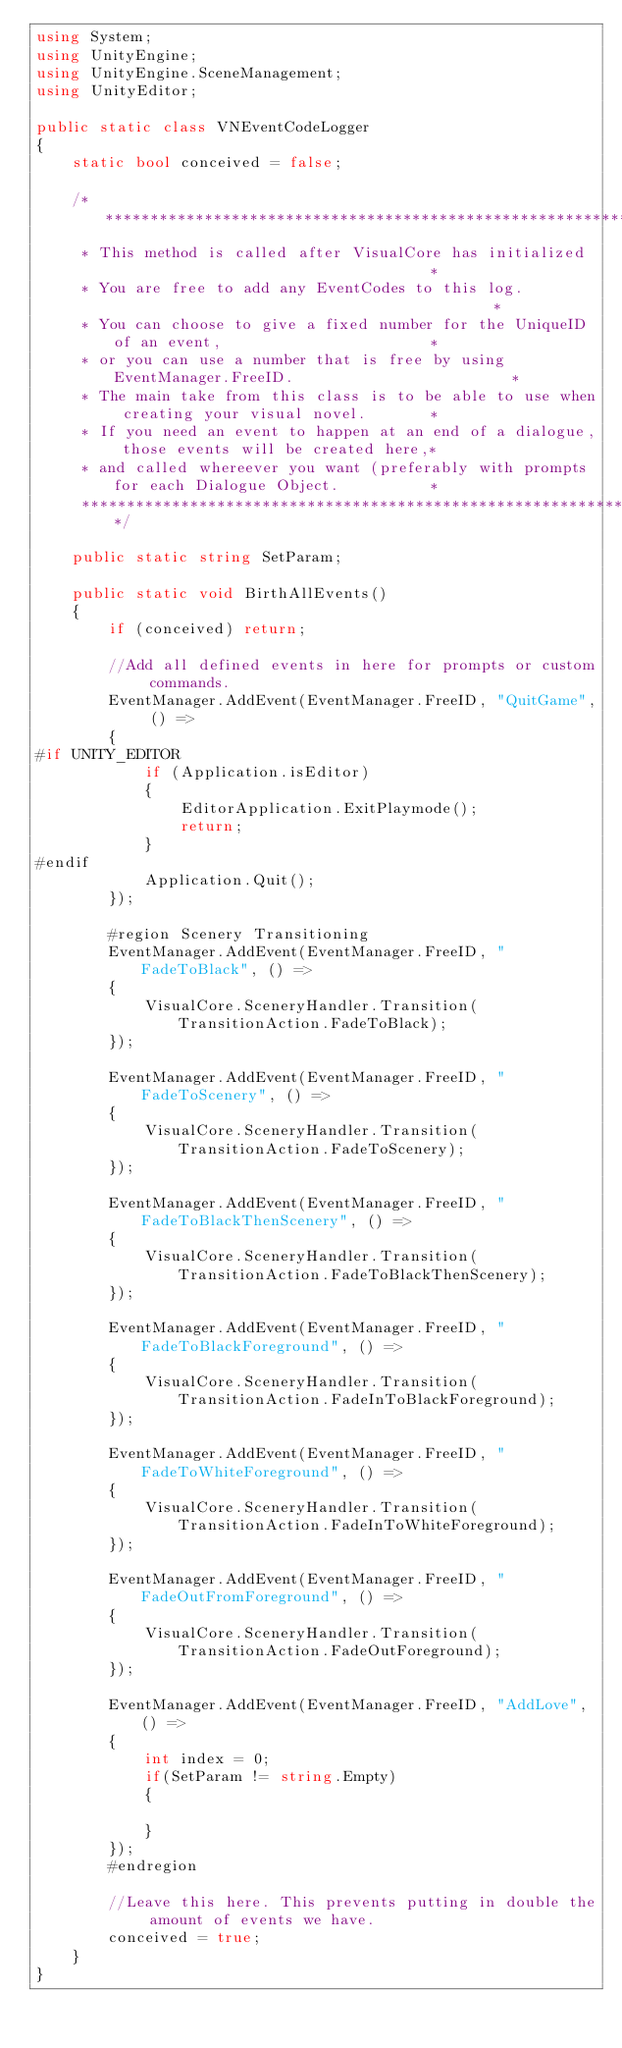<code> <loc_0><loc_0><loc_500><loc_500><_C#_>using System;
using UnityEngine;
using UnityEngine.SceneManagement;
using UnityEditor;

public static class VNEventCodeLogger
{
    static bool conceived = false;

    /*********************************************************************************************
     * This method is called after VisualCore has initialized                                    *
     * You are free to add any EventCodes to this log.                                           *
     * You can choose to give a fixed number for the UniqueID of an event,                       *
     * or you can use a number that is free by using EventManager.FreeID.                        *
     * The main take from this class is to be able to use when creating your visual novel.       *
     * If you need an event to happen at an end of a dialogue, those events will be created here,*
     * and called whereever you want (preferably with prompts for each Dialogue Object.          *
     ********************************************************************************************/

    public static string SetParam;

    public static void BirthAllEvents()
    {
        if (conceived) return;

        //Add all defined events in here for prompts or custom commands.
        EventManager.AddEvent(EventManager.FreeID, "QuitGame", () =>
        {
#if UNITY_EDITOR
            if (Application.isEditor)
            {
                EditorApplication.ExitPlaymode();
                return;
            }
#endif 
            Application.Quit();
        });

        #region Scenery Transitioning
        EventManager.AddEvent(EventManager.FreeID, "FadeToBlack", () =>
        {
            VisualCore.SceneryHandler.Transition(TransitionAction.FadeToBlack);
        });

        EventManager.AddEvent(EventManager.FreeID, "FadeToScenery", () =>
        {
            VisualCore.SceneryHandler.Transition(TransitionAction.FadeToScenery);
        });

        EventManager.AddEvent(EventManager.FreeID, "FadeToBlackThenScenery", () =>
        {
            VisualCore.SceneryHandler.Transition(TransitionAction.FadeToBlackThenScenery);
        });

        EventManager.AddEvent(EventManager.FreeID, "FadeToBlackForeground", () =>
        {
            VisualCore.SceneryHandler.Transition(TransitionAction.FadeInToBlackForeground);
        });

        EventManager.AddEvent(EventManager.FreeID, "FadeToWhiteForeground", () =>
        {
            VisualCore.SceneryHandler.Transition(TransitionAction.FadeInToWhiteForeground);
        });

        EventManager.AddEvent(EventManager.FreeID, "FadeOutFromForeground", () =>
        {
            VisualCore.SceneryHandler.Transition(TransitionAction.FadeOutForeground);
        });

        EventManager.AddEvent(EventManager.FreeID, "AddLove", () =>
        {
            int index = 0;
            if(SetParam != string.Empty)
            {

            }
        });
        #endregion

        //Leave this here. This prevents putting in double the amount of events we have.
        conceived = true;
    }
}
</code> 